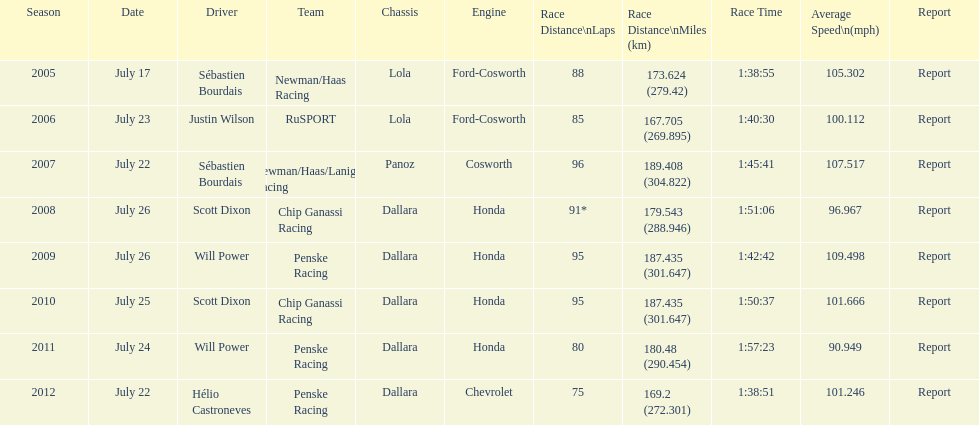How many flags other than france (the first flag) are represented? 3. 